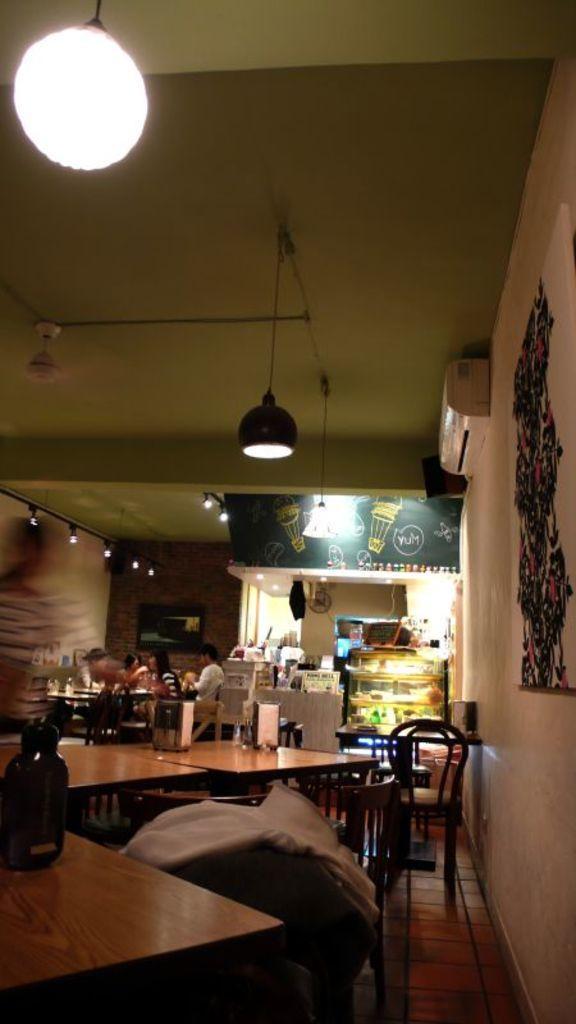Describe this image in one or two sentences. This picture shows an inner view of a restaurant where few people seated and we see few chairs and tables. 